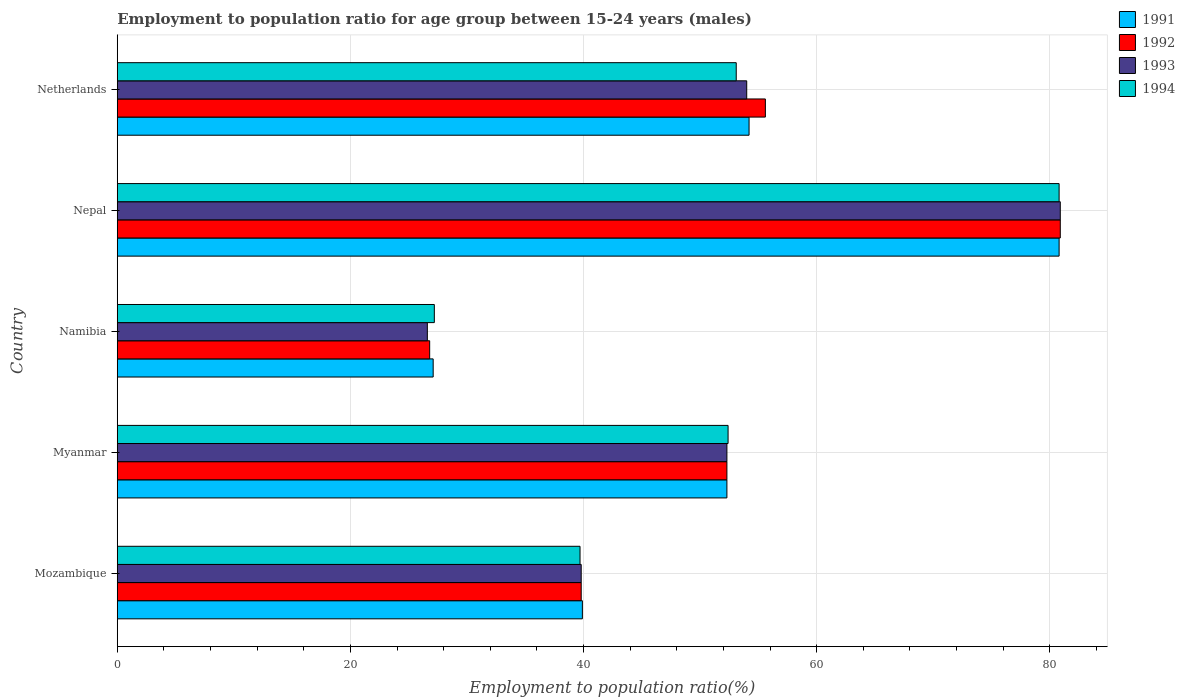How many different coloured bars are there?
Keep it short and to the point. 4. What is the label of the 2nd group of bars from the top?
Give a very brief answer. Nepal. What is the employment to population ratio in 1992 in Myanmar?
Offer a very short reply. 52.3. Across all countries, what is the maximum employment to population ratio in 1993?
Offer a terse response. 80.9. Across all countries, what is the minimum employment to population ratio in 1991?
Keep it short and to the point. 27.1. In which country was the employment to population ratio in 1994 maximum?
Keep it short and to the point. Nepal. In which country was the employment to population ratio in 1993 minimum?
Make the answer very short. Namibia. What is the total employment to population ratio in 1992 in the graph?
Make the answer very short. 255.4. What is the difference between the employment to population ratio in 1994 in Namibia and that in Nepal?
Ensure brevity in your answer.  -53.6. What is the difference between the employment to population ratio in 1993 in Netherlands and the employment to population ratio in 1992 in Nepal?
Your answer should be compact. -26.9. What is the average employment to population ratio in 1991 per country?
Give a very brief answer. 50.86. What is the difference between the employment to population ratio in 1991 and employment to population ratio in 1993 in Netherlands?
Keep it short and to the point. 0.2. In how many countries, is the employment to population ratio in 1994 greater than 32 %?
Your response must be concise. 4. What is the ratio of the employment to population ratio in 1991 in Namibia to that in Netherlands?
Offer a terse response. 0.5. Is the difference between the employment to population ratio in 1991 in Myanmar and Nepal greater than the difference between the employment to population ratio in 1993 in Myanmar and Nepal?
Your answer should be very brief. Yes. What is the difference between the highest and the second highest employment to population ratio in 1994?
Keep it short and to the point. 27.7. What is the difference between the highest and the lowest employment to population ratio in 1994?
Offer a terse response. 53.6. In how many countries, is the employment to population ratio in 1992 greater than the average employment to population ratio in 1992 taken over all countries?
Offer a very short reply. 3. What does the 4th bar from the bottom in Mozambique represents?
Provide a short and direct response. 1994. How many countries are there in the graph?
Your answer should be very brief. 5. What is the difference between two consecutive major ticks on the X-axis?
Your answer should be very brief. 20. How are the legend labels stacked?
Give a very brief answer. Vertical. What is the title of the graph?
Your answer should be compact. Employment to population ratio for age group between 15-24 years (males). Does "2000" appear as one of the legend labels in the graph?
Your response must be concise. No. What is the Employment to population ratio(%) of 1991 in Mozambique?
Your answer should be very brief. 39.9. What is the Employment to population ratio(%) of 1992 in Mozambique?
Keep it short and to the point. 39.8. What is the Employment to population ratio(%) in 1993 in Mozambique?
Your answer should be very brief. 39.8. What is the Employment to population ratio(%) of 1994 in Mozambique?
Provide a succinct answer. 39.7. What is the Employment to population ratio(%) of 1991 in Myanmar?
Your answer should be compact. 52.3. What is the Employment to population ratio(%) in 1992 in Myanmar?
Give a very brief answer. 52.3. What is the Employment to population ratio(%) of 1993 in Myanmar?
Make the answer very short. 52.3. What is the Employment to population ratio(%) of 1994 in Myanmar?
Offer a terse response. 52.4. What is the Employment to population ratio(%) in 1991 in Namibia?
Offer a very short reply. 27.1. What is the Employment to population ratio(%) in 1992 in Namibia?
Offer a very short reply. 26.8. What is the Employment to population ratio(%) in 1993 in Namibia?
Provide a succinct answer. 26.6. What is the Employment to population ratio(%) in 1994 in Namibia?
Give a very brief answer. 27.2. What is the Employment to population ratio(%) in 1991 in Nepal?
Give a very brief answer. 80.8. What is the Employment to population ratio(%) in 1992 in Nepal?
Offer a very short reply. 80.9. What is the Employment to population ratio(%) of 1993 in Nepal?
Your answer should be very brief. 80.9. What is the Employment to population ratio(%) of 1994 in Nepal?
Provide a succinct answer. 80.8. What is the Employment to population ratio(%) of 1991 in Netherlands?
Your response must be concise. 54.2. What is the Employment to population ratio(%) of 1992 in Netherlands?
Ensure brevity in your answer.  55.6. What is the Employment to population ratio(%) of 1994 in Netherlands?
Make the answer very short. 53.1. Across all countries, what is the maximum Employment to population ratio(%) of 1991?
Your answer should be compact. 80.8. Across all countries, what is the maximum Employment to population ratio(%) in 1992?
Your answer should be very brief. 80.9. Across all countries, what is the maximum Employment to population ratio(%) of 1993?
Ensure brevity in your answer.  80.9. Across all countries, what is the maximum Employment to population ratio(%) of 1994?
Ensure brevity in your answer.  80.8. Across all countries, what is the minimum Employment to population ratio(%) in 1991?
Your response must be concise. 27.1. Across all countries, what is the minimum Employment to population ratio(%) of 1992?
Ensure brevity in your answer.  26.8. Across all countries, what is the minimum Employment to population ratio(%) in 1993?
Offer a terse response. 26.6. Across all countries, what is the minimum Employment to population ratio(%) of 1994?
Provide a short and direct response. 27.2. What is the total Employment to population ratio(%) in 1991 in the graph?
Provide a short and direct response. 254.3. What is the total Employment to population ratio(%) of 1992 in the graph?
Ensure brevity in your answer.  255.4. What is the total Employment to population ratio(%) of 1993 in the graph?
Keep it short and to the point. 253.6. What is the total Employment to population ratio(%) in 1994 in the graph?
Keep it short and to the point. 253.2. What is the difference between the Employment to population ratio(%) in 1991 in Mozambique and that in Myanmar?
Your answer should be very brief. -12.4. What is the difference between the Employment to population ratio(%) of 1992 in Mozambique and that in Myanmar?
Give a very brief answer. -12.5. What is the difference between the Employment to population ratio(%) of 1994 in Mozambique and that in Myanmar?
Provide a short and direct response. -12.7. What is the difference between the Employment to population ratio(%) in 1991 in Mozambique and that in Namibia?
Give a very brief answer. 12.8. What is the difference between the Employment to population ratio(%) of 1994 in Mozambique and that in Namibia?
Your answer should be very brief. 12.5. What is the difference between the Employment to population ratio(%) in 1991 in Mozambique and that in Nepal?
Offer a very short reply. -40.9. What is the difference between the Employment to population ratio(%) of 1992 in Mozambique and that in Nepal?
Offer a terse response. -41.1. What is the difference between the Employment to population ratio(%) of 1993 in Mozambique and that in Nepal?
Offer a very short reply. -41.1. What is the difference between the Employment to population ratio(%) in 1994 in Mozambique and that in Nepal?
Your answer should be very brief. -41.1. What is the difference between the Employment to population ratio(%) in 1991 in Mozambique and that in Netherlands?
Ensure brevity in your answer.  -14.3. What is the difference between the Employment to population ratio(%) in 1992 in Mozambique and that in Netherlands?
Give a very brief answer. -15.8. What is the difference between the Employment to population ratio(%) in 1994 in Mozambique and that in Netherlands?
Make the answer very short. -13.4. What is the difference between the Employment to population ratio(%) of 1991 in Myanmar and that in Namibia?
Give a very brief answer. 25.2. What is the difference between the Employment to population ratio(%) of 1993 in Myanmar and that in Namibia?
Offer a very short reply. 25.7. What is the difference between the Employment to population ratio(%) in 1994 in Myanmar and that in Namibia?
Give a very brief answer. 25.2. What is the difference between the Employment to population ratio(%) in 1991 in Myanmar and that in Nepal?
Ensure brevity in your answer.  -28.5. What is the difference between the Employment to population ratio(%) of 1992 in Myanmar and that in Nepal?
Your answer should be very brief. -28.6. What is the difference between the Employment to population ratio(%) of 1993 in Myanmar and that in Nepal?
Your response must be concise. -28.6. What is the difference between the Employment to population ratio(%) of 1994 in Myanmar and that in Nepal?
Give a very brief answer. -28.4. What is the difference between the Employment to population ratio(%) of 1993 in Myanmar and that in Netherlands?
Your answer should be compact. -1.7. What is the difference between the Employment to population ratio(%) of 1991 in Namibia and that in Nepal?
Ensure brevity in your answer.  -53.7. What is the difference between the Employment to population ratio(%) in 1992 in Namibia and that in Nepal?
Offer a terse response. -54.1. What is the difference between the Employment to population ratio(%) of 1993 in Namibia and that in Nepal?
Provide a succinct answer. -54.3. What is the difference between the Employment to population ratio(%) in 1994 in Namibia and that in Nepal?
Offer a very short reply. -53.6. What is the difference between the Employment to population ratio(%) of 1991 in Namibia and that in Netherlands?
Provide a succinct answer. -27.1. What is the difference between the Employment to population ratio(%) in 1992 in Namibia and that in Netherlands?
Your answer should be very brief. -28.8. What is the difference between the Employment to population ratio(%) of 1993 in Namibia and that in Netherlands?
Offer a terse response. -27.4. What is the difference between the Employment to population ratio(%) of 1994 in Namibia and that in Netherlands?
Make the answer very short. -25.9. What is the difference between the Employment to population ratio(%) in 1991 in Nepal and that in Netherlands?
Your answer should be very brief. 26.6. What is the difference between the Employment to population ratio(%) in 1992 in Nepal and that in Netherlands?
Provide a short and direct response. 25.3. What is the difference between the Employment to population ratio(%) of 1993 in Nepal and that in Netherlands?
Keep it short and to the point. 26.9. What is the difference between the Employment to population ratio(%) in 1994 in Nepal and that in Netherlands?
Provide a short and direct response. 27.7. What is the difference between the Employment to population ratio(%) in 1991 in Mozambique and the Employment to population ratio(%) in 1992 in Myanmar?
Offer a terse response. -12.4. What is the difference between the Employment to population ratio(%) of 1991 in Mozambique and the Employment to population ratio(%) of 1993 in Myanmar?
Your response must be concise. -12.4. What is the difference between the Employment to population ratio(%) in 1992 in Mozambique and the Employment to population ratio(%) in 1994 in Myanmar?
Give a very brief answer. -12.6. What is the difference between the Employment to population ratio(%) in 1993 in Mozambique and the Employment to population ratio(%) in 1994 in Myanmar?
Ensure brevity in your answer.  -12.6. What is the difference between the Employment to population ratio(%) of 1991 in Mozambique and the Employment to population ratio(%) of 1992 in Namibia?
Ensure brevity in your answer.  13.1. What is the difference between the Employment to population ratio(%) of 1991 in Mozambique and the Employment to population ratio(%) of 1993 in Namibia?
Give a very brief answer. 13.3. What is the difference between the Employment to population ratio(%) of 1992 in Mozambique and the Employment to population ratio(%) of 1993 in Namibia?
Your response must be concise. 13.2. What is the difference between the Employment to population ratio(%) in 1993 in Mozambique and the Employment to population ratio(%) in 1994 in Namibia?
Offer a terse response. 12.6. What is the difference between the Employment to population ratio(%) of 1991 in Mozambique and the Employment to population ratio(%) of 1992 in Nepal?
Your answer should be compact. -41. What is the difference between the Employment to population ratio(%) in 1991 in Mozambique and the Employment to population ratio(%) in 1993 in Nepal?
Your response must be concise. -41. What is the difference between the Employment to population ratio(%) of 1991 in Mozambique and the Employment to population ratio(%) of 1994 in Nepal?
Ensure brevity in your answer.  -40.9. What is the difference between the Employment to population ratio(%) in 1992 in Mozambique and the Employment to population ratio(%) in 1993 in Nepal?
Give a very brief answer. -41.1. What is the difference between the Employment to population ratio(%) in 1992 in Mozambique and the Employment to population ratio(%) in 1994 in Nepal?
Your answer should be very brief. -41. What is the difference between the Employment to population ratio(%) in 1993 in Mozambique and the Employment to population ratio(%) in 1994 in Nepal?
Give a very brief answer. -41. What is the difference between the Employment to population ratio(%) in 1991 in Mozambique and the Employment to population ratio(%) in 1992 in Netherlands?
Your answer should be compact. -15.7. What is the difference between the Employment to population ratio(%) of 1991 in Mozambique and the Employment to population ratio(%) of 1993 in Netherlands?
Provide a succinct answer. -14.1. What is the difference between the Employment to population ratio(%) in 1992 in Mozambique and the Employment to population ratio(%) in 1993 in Netherlands?
Provide a short and direct response. -14.2. What is the difference between the Employment to population ratio(%) in 1992 in Mozambique and the Employment to population ratio(%) in 1994 in Netherlands?
Offer a terse response. -13.3. What is the difference between the Employment to population ratio(%) of 1993 in Mozambique and the Employment to population ratio(%) of 1994 in Netherlands?
Your response must be concise. -13.3. What is the difference between the Employment to population ratio(%) of 1991 in Myanmar and the Employment to population ratio(%) of 1992 in Namibia?
Your answer should be compact. 25.5. What is the difference between the Employment to population ratio(%) in 1991 in Myanmar and the Employment to population ratio(%) in 1993 in Namibia?
Your answer should be very brief. 25.7. What is the difference between the Employment to population ratio(%) of 1991 in Myanmar and the Employment to population ratio(%) of 1994 in Namibia?
Keep it short and to the point. 25.1. What is the difference between the Employment to population ratio(%) of 1992 in Myanmar and the Employment to population ratio(%) of 1993 in Namibia?
Offer a very short reply. 25.7. What is the difference between the Employment to population ratio(%) of 1992 in Myanmar and the Employment to population ratio(%) of 1994 in Namibia?
Ensure brevity in your answer.  25.1. What is the difference between the Employment to population ratio(%) in 1993 in Myanmar and the Employment to population ratio(%) in 1994 in Namibia?
Offer a terse response. 25.1. What is the difference between the Employment to population ratio(%) in 1991 in Myanmar and the Employment to population ratio(%) in 1992 in Nepal?
Ensure brevity in your answer.  -28.6. What is the difference between the Employment to population ratio(%) of 1991 in Myanmar and the Employment to population ratio(%) of 1993 in Nepal?
Your answer should be very brief. -28.6. What is the difference between the Employment to population ratio(%) in 1991 in Myanmar and the Employment to population ratio(%) in 1994 in Nepal?
Provide a short and direct response. -28.5. What is the difference between the Employment to population ratio(%) in 1992 in Myanmar and the Employment to population ratio(%) in 1993 in Nepal?
Your answer should be compact. -28.6. What is the difference between the Employment to population ratio(%) in 1992 in Myanmar and the Employment to population ratio(%) in 1994 in Nepal?
Provide a succinct answer. -28.5. What is the difference between the Employment to population ratio(%) of 1993 in Myanmar and the Employment to population ratio(%) of 1994 in Nepal?
Your answer should be compact. -28.5. What is the difference between the Employment to population ratio(%) of 1991 in Myanmar and the Employment to population ratio(%) of 1992 in Netherlands?
Give a very brief answer. -3.3. What is the difference between the Employment to population ratio(%) of 1992 in Myanmar and the Employment to population ratio(%) of 1994 in Netherlands?
Offer a terse response. -0.8. What is the difference between the Employment to population ratio(%) in 1993 in Myanmar and the Employment to population ratio(%) in 1994 in Netherlands?
Your answer should be compact. -0.8. What is the difference between the Employment to population ratio(%) of 1991 in Namibia and the Employment to population ratio(%) of 1992 in Nepal?
Your answer should be very brief. -53.8. What is the difference between the Employment to population ratio(%) of 1991 in Namibia and the Employment to population ratio(%) of 1993 in Nepal?
Your response must be concise. -53.8. What is the difference between the Employment to population ratio(%) of 1991 in Namibia and the Employment to population ratio(%) of 1994 in Nepal?
Make the answer very short. -53.7. What is the difference between the Employment to population ratio(%) of 1992 in Namibia and the Employment to population ratio(%) of 1993 in Nepal?
Keep it short and to the point. -54.1. What is the difference between the Employment to population ratio(%) in 1992 in Namibia and the Employment to population ratio(%) in 1994 in Nepal?
Offer a terse response. -54. What is the difference between the Employment to population ratio(%) of 1993 in Namibia and the Employment to population ratio(%) of 1994 in Nepal?
Ensure brevity in your answer.  -54.2. What is the difference between the Employment to population ratio(%) of 1991 in Namibia and the Employment to population ratio(%) of 1992 in Netherlands?
Offer a terse response. -28.5. What is the difference between the Employment to population ratio(%) in 1991 in Namibia and the Employment to population ratio(%) in 1993 in Netherlands?
Ensure brevity in your answer.  -26.9. What is the difference between the Employment to population ratio(%) of 1992 in Namibia and the Employment to population ratio(%) of 1993 in Netherlands?
Your answer should be compact. -27.2. What is the difference between the Employment to population ratio(%) in 1992 in Namibia and the Employment to population ratio(%) in 1994 in Netherlands?
Offer a terse response. -26.3. What is the difference between the Employment to population ratio(%) in 1993 in Namibia and the Employment to population ratio(%) in 1994 in Netherlands?
Ensure brevity in your answer.  -26.5. What is the difference between the Employment to population ratio(%) in 1991 in Nepal and the Employment to population ratio(%) in 1992 in Netherlands?
Offer a terse response. 25.2. What is the difference between the Employment to population ratio(%) of 1991 in Nepal and the Employment to population ratio(%) of 1993 in Netherlands?
Provide a short and direct response. 26.8. What is the difference between the Employment to population ratio(%) in 1991 in Nepal and the Employment to population ratio(%) in 1994 in Netherlands?
Offer a terse response. 27.7. What is the difference between the Employment to population ratio(%) in 1992 in Nepal and the Employment to population ratio(%) in 1993 in Netherlands?
Your response must be concise. 26.9. What is the difference between the Employment to population ratio(%) in 1992 in Nepal and the Employment to population ratio(%) in 1994 in Netherlands?
Give a very brief answer. 27.8. What is the difference between the Employment to population ratio(%) in 1993 in Nepal and the Employment to population ratio(%) in 1994 in Netherlands?
Make the answer very short. 27.8. What is the average Employment to population ratio(%) of 1991 per country?
Your answer should be compact. 50.86. What is the average Employment to population ratio(%) in 1992 per country?
Your answer should be compact. 51.08. What is the average Employment to population ratio(%) in 1993 per country?
Give a very brief answer. 50.72. What is the average Employment to population ratio(%) in 1994 per country?
Give a very brief answer. 50.64. What is the difference between the Employment to population ratio(%) in 1991 and Employment to population ratio(%) in 1992 in Mozambique?
Your response must be concise. 0.1. What is the difference between the Employment to population ratio(%) in 1991 and Employment to population ratio(%) in 1993 in Mozambique?
Offer a very short reply. 0.1. What is the difference between the Employment to population ratio(%) of 1992 and Employment to population ratio(%) of 1993 in Mozambique?
Offer a terse response. 0. What is the difference between the Employment to population ratio(%) of 1991 and Employment to population ratio(%) of 1993 in Myanmar?
Give a very brief answer. 0. What is the difference between the Employment to population ratio(%) of 1991 and Employment to population ratio(%) of 1994 in Myanmar?
Offer a terse response. -0.1. What is the difference between the Employment to population ratio(%) of 1992 and Employment to population ratio(%) of 1994 in Myanmar?
Ensure brevity in your answer.  -0.1. What is the difference between the Employment to population ratio(%) of 1993 and Employment to population ratio(%) of 1994 in Myanmar?
Your answer should be compact. -0.1. What is the difference between the Employment to population ratio(%) of 1991 and Employment to population ratio(%) of 1992 in Namibia?
Make the answer very short. 0.3. What is the difference between the Employment to population ratio(%) in 1991 and Employment to population ratio(%) in 1994 in Namibia?
Give a very brief answer. -0.1. What is the difference between the Employment to population ratio(%) of 1992 and Employment to population ratio(%) of 1994 in Namibia?
Give a very brief answer. -0.4. What is the difference between the Employment to population ratio(%) of 1991 and Employment to population ratio(%) of 1993 in Nepal?
Keep it short and to the point. -0.1. What is the difference between the Employment to population ratio(%) in 1991 and Employment to population ratio(%) in 1993 in Netherlands?
Your response must be concise. 0.2. What is the difference between the Employment to population ratio(%) in 1992 and Employment to population ratio(%) in 1993 in Netherlands?
Your answer should be very brief. 1.6. What is the difference between the Employment to population ratio(%) in 1993 and Employment to population ratio(%) in 1994 in Netherlands?
Offer a terse response. 0.9. What is the ratio of the Employment to population ratio(%) of 1991 in Mozambique to that in Myanmar?
Provide a succinct answer. 0.76. What is the ratio of the Employment to population ratio(%) in 1992 in Mozambique to that in Myanmar?
Ensure brevity in your answer.  0.76. What is the ratio of the Employment to population ratio(%) in 1993 in Mozambique to that in Myanmar?
Provide a short and direct response. 0.76. What is the ratio of the Employment to population ratio(%) of 1994 in Mozambique to that in Myanmar?
Keep it short and to the point. 0.76. What is the ratio of the Employment to population ratio(%) in 1991 in Mozambique to that in Namibia?
Keep it short and to the point. 1.47. What is the ratio of the Employment to population ratio(%) of 1992 in Mozambique to that in Namibia?
Provide a short and direct response. 1.49. What is the ratio of the Employment to population ratio(%) in 1993 in Mozambique to that in Namibia?
Give a very brief answer. 1.5. What is the ratio of the Employment to population ratio(%) in 1994 in Mozambique to that in Namibia?
Provide a short and direct response. 1.46. What is the ratio of the Employment to population ratio(%) of 1991 in Mozambique to that in Nepal?
Your response must be concise. 0.49. What is the ratio of the Employment to population ratio(%) of 1992 in Mozambique to that in Nepal?
Your answer should be compact. 0.49. What is the ratio of the Employment to population ratio(%) in 1993 in Mozambique to that in Nepal?
Provide a short and direct response. 0.49. What is the ratio of the Employment to population ratio(%) of 1994 in Mozambique to that in Nepal?
Ensure brevity in your answer.  0.49. What is the ratio of the Employment to population ratio(%) in 1991 in Mozambique to that in Netherlands?
Offer a very short reply. 0.74. What is the ratio of the Employment to population ratio(%) of 1992 in Mozambique to that in Netherlands?
Your answer should be compact. 0.72. What is the ratio of the Employment to population ratio(%) in 1993 in Mozambique to that in Netherlands?
Offer a terse response. 0.74. What is the ratio of the Employment to population ratio(%) in 1994 in Mozambique to that in Netherlands?
Give a very brief answer. 0.75. What is the ratio of the Employment to population ratio(%) of 1991 in Myanmar to that in Namibia?
Keep it short and to the point. 1.93. What is the ratio of the Employment to population ratio(%) in 1992 in Myanmar to that in Namibia?
Provide a short and direct response. 1.95. What is the ratio of the Employment to population ratio(%) in 1993 in Myanmar to that in Namibia?
Provide a succinct answer. 1.97. What is the ratio of the Employment to population ratio(%) of 1994 in Myanmar to that in Namibia?
Make the answer very short. 1.93. What is the ratio of the Employment to population ratio(%) of 1991 in Myanmar to that in Nepal?
Ensure brevity in your answer.  0.65. What is the ratio of the Employment to population ratio(%) in 1992 in Myanmar to that in Nepal?
Your answer should be compact. 0.65. What is the ratio of the Employment to population ratio(%) in 1993 in Myanmar to that in Nepal?
Give a very brief answer. 0.65. What is the ratio of the Employment to population ratio(%) of 1994 in Myanmar to that in Nepal?
Provide a succinct answer. 0.65. What is the ratio of the Employment to population ratio(%) in 1991 in Myanmar to that in Netherlands?
Ensure brevity in your answer.  0.96. What is the ratio of the Employment to population ratio(%) of 1992 in Myanmar to that in Netherlands?
Your answer should be very brief. 0.94. What is the ratio of the Employment to population ratio(%) in 1993 in Myanmar to that in Netherlands?
Offer a terse response. 0.97. What is the ratio of the Employment to population ratio(%) of 1991 in Namibia to that in Nepal?
Provide a short and direct response. 0.34. What is the ratio of the Employment to population ratio(%) of 1992 in Namibia to that in Nepal?
Your response must be concise. 0.33. What is the ratio of the Employment to population ratio(%) in 1993 in Namibia to that in Nepal?
Your response must be concise. 0.33. What is the ratio of the Employment to population ratio(%) in 1994 in Namibia to that in Nepal?
Offer a terse response. 0.34. What is the ratio of the Employment to population ratio(%) in 1991 in Namibia to that in Netherlands?
Offer a terse response. 0.5. What is the ratio of the Employment to population ratio(%) in 1992 in Namibia to that in Netherlands?
Offer a terse response. 0.48. What is the ratio of the Employment to population ratio(%) in 1993 in Namibia to that in Netherlands?
Offer a terse response. 0.49. What is the ratio of the Employment to population ratio(%) of 1994 in Namibia to that in Netherlands?
Offer a very short reply. 0.51. What is the ratio of the Employment to population ratio(%) of 1991 in Nepal to that in Netherlands?
Give a very brief answer. 1.49. What is the ratio of the Employment to population ratio(%) in 1992 in Nepal to that in Netherlands?
Make the answer very short. 1.46. What is the ratio of the Employment to population ratio(%) of 1993 in Nepal to that in Netherlands?
Your response must be concise. 1.5. What is the ratio of the Employment to population ratio(%) of 1994 in Nepal to that in Netherlands?
Offer a terse response. 1.52. What is the difference between the highest and the second highest Employment to population ratio(%) of 1991?
Your answer should be compact. 26.6. What is the difference between the highest and the second highest Employment to population ratio(%) of 1992?
Your answer should be compact. 25.3. What is the difference between the highest and the second highest Employment to population ratio(%) of 1993?
Ensure brevity in your answer.  26.9. What is the difference between the highest and the second highest Employment to population ratio(%) of 1994?
Provide a succinct answer. 27.7. What is the difference between the highest and the lowest Employment to population ratio(%) of 1991?
Offer a terse response. 53.7. What is the difference between the highest and the lowest Employment to population ratio(%) of 1992?
Offer a very short reply. 54.1. What is the difference between the highest and the lowest Employment to population ratio(%) in 1993?
Provide a succinct answer. 54.3. What is the difference between the highest and the lowest Employment to population ratio(%) of 1994?
Your response must be concise. 53.6. 